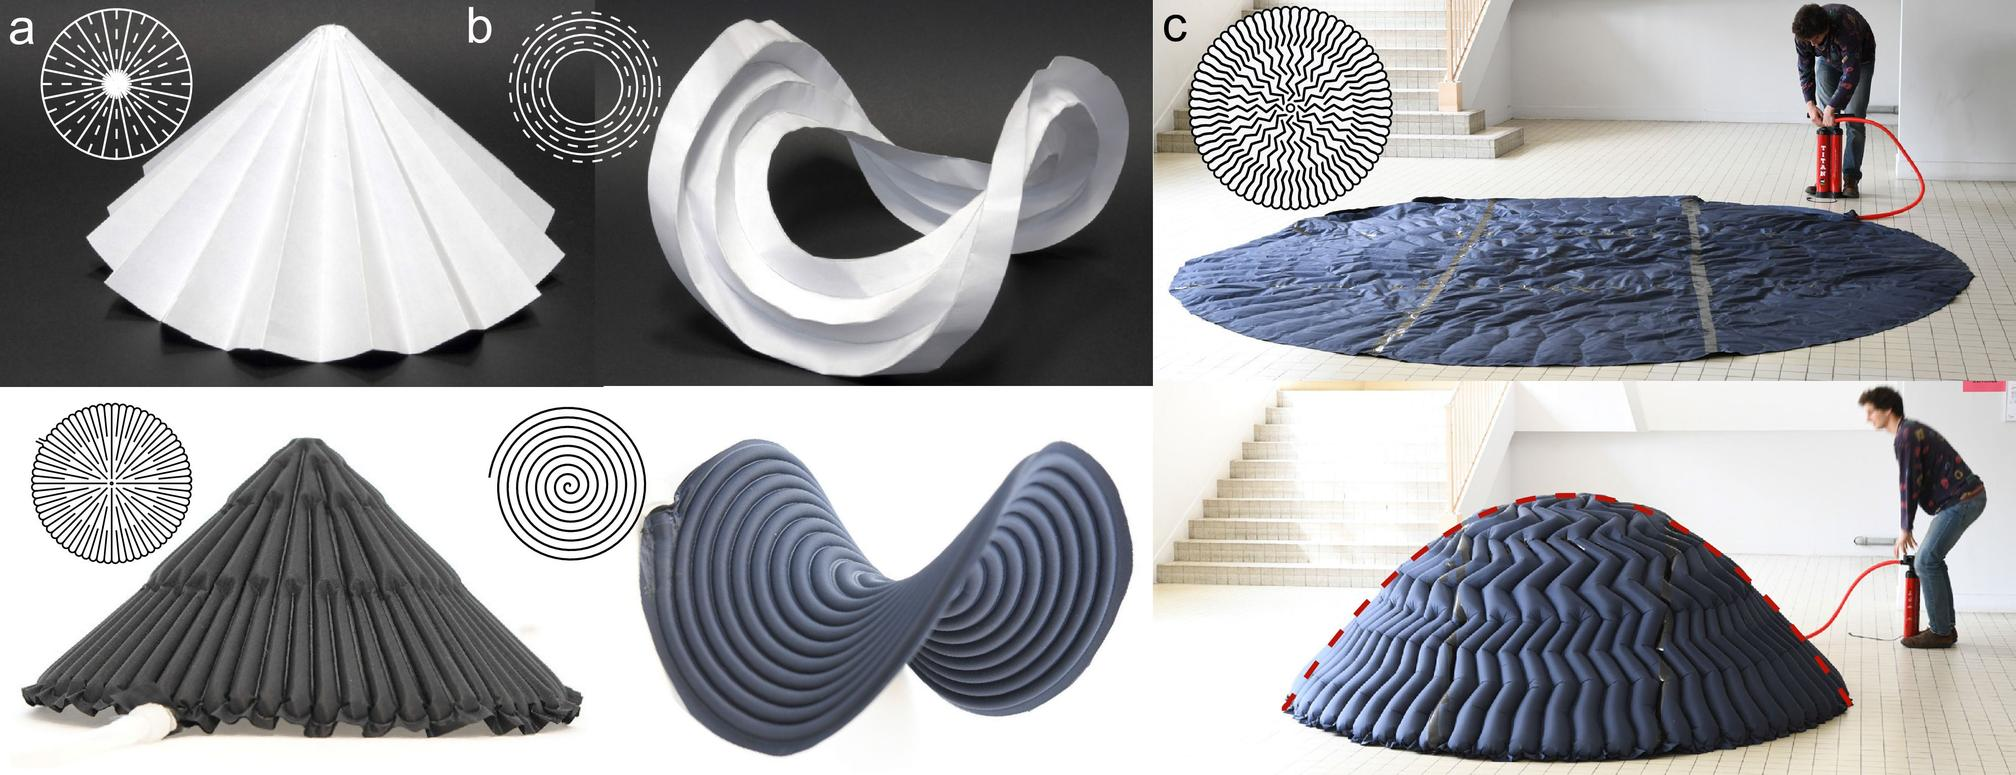What process is being demonstrated in figure (a)? Figure (a) depicts an intricate process where a flat sheet has been expertly folded into a conical shape. This is evident from the symmetrical fold lines emanating from the center towards the edges, illustrating a methodical approach to transforming a two-dimensional material into a three-dimensional object. This technique is commonly used in artistic and engineering contexts to explore forms and structures that are both functional and visually appealing. 